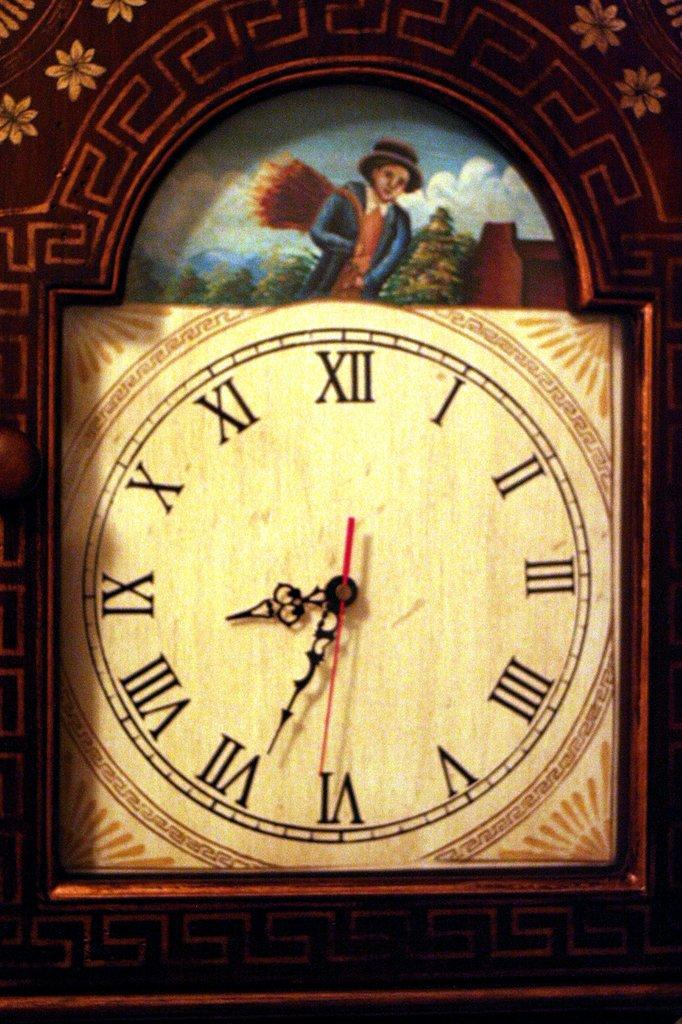Provide a one-sentence caption for the provided image. Roman numeral clock with a man in a picture in the middle of the clock. 